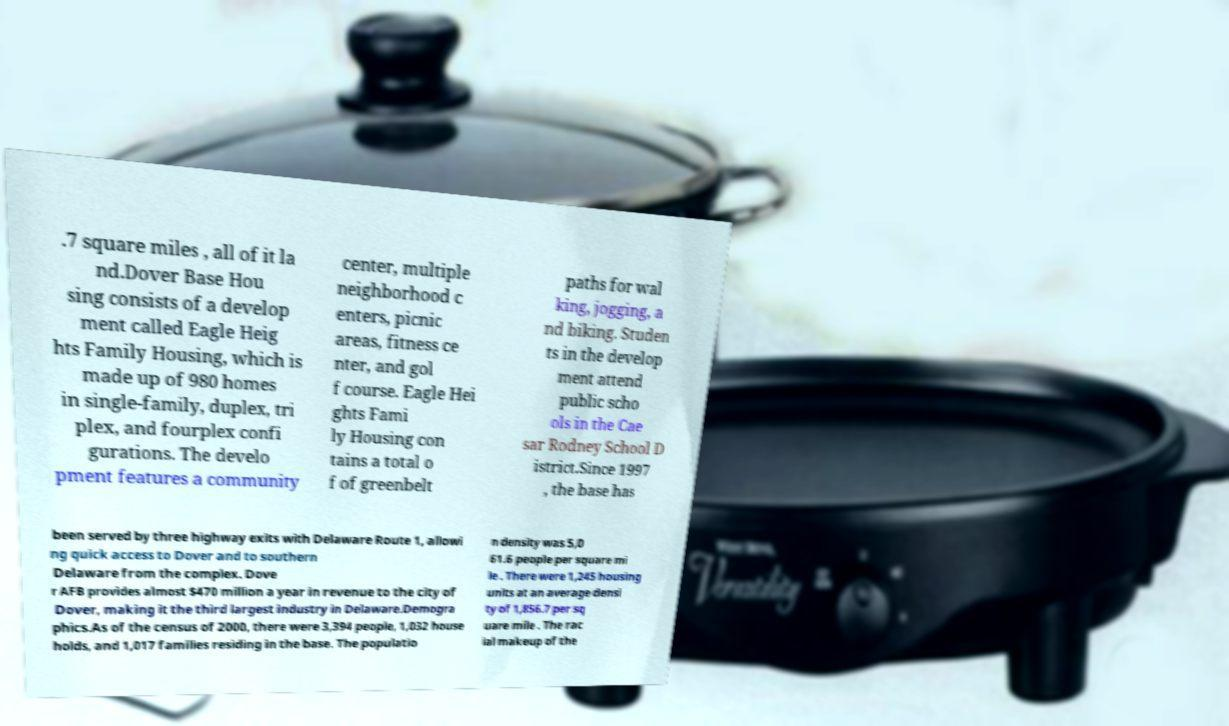Can you accurately transcribe the text from the provided image for me? .7 square miles , all of it la nd.Dover Base Hou sing consists of a develop ment called Eagle Heig hts Family Housing, which is made up of 980 homes in single-family, duplex, tri plex, and fourplex confi gurations. The develo pment features a community center, multiple neighborhood c enters, picnic areas, fitness ce nter, and gol f course. Eagle Hei ghts Fami ly Housing con tains a total o f of greenbelt paths for wal king, jogging, a nd biking. Studen ts in the develop ment attend public scho ols in the Cae sar Rodney School D istrict.Since 1997 , the base has been served by three highway exits with Delaware Route 1, allowi ng quick access to Dover and to southern Delaware from the complex. Dove r AFB provides almost $470 million a year in revenue to the city of Dover, making it the third largest industry in Delaware.Demogra phics.As of the census of 2000, there were 3,394 people, 1,032 house holds, and 1,017 families residing in the base. The populatio n density was 5,0 61.6 people per square mi le . There were 1,245 housing units at an average densi ty of 1,856.7 per sq uare mile . The rac ial makeup of the 